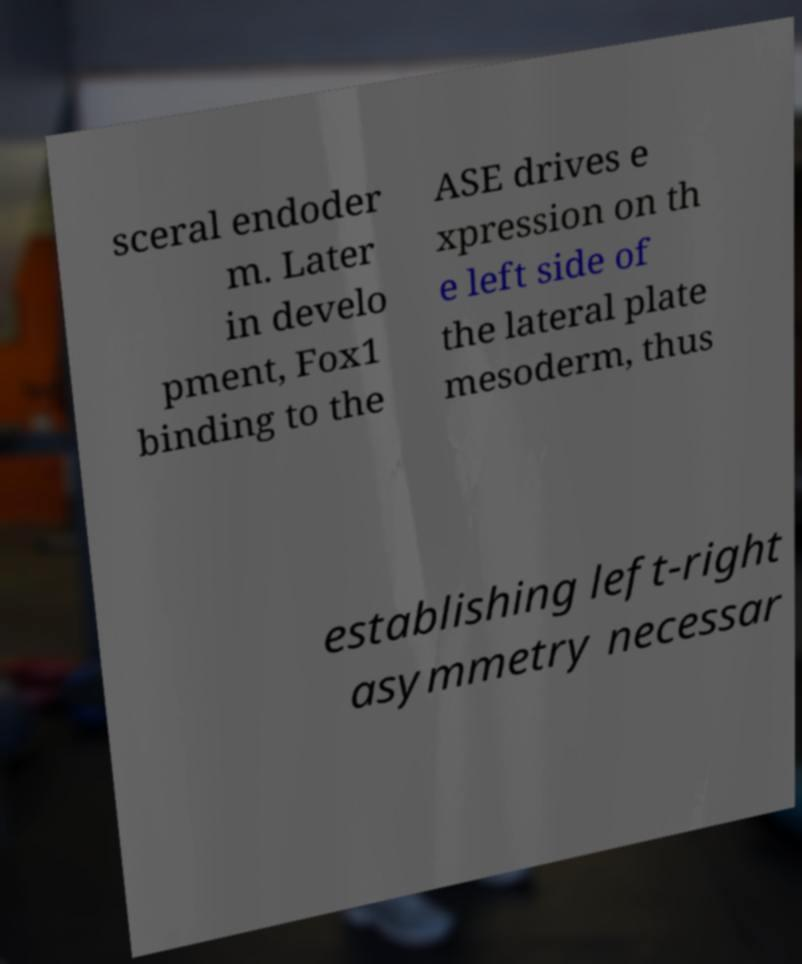Could you assist in decoding the text presented in this image and type it out clearly? sceral endoder m. Later in develo pment, Fox1 binding to the ASE drives e xpression on th e left side of the lateral plate mesoderm, thus establishing left-right asymmetry necessar 